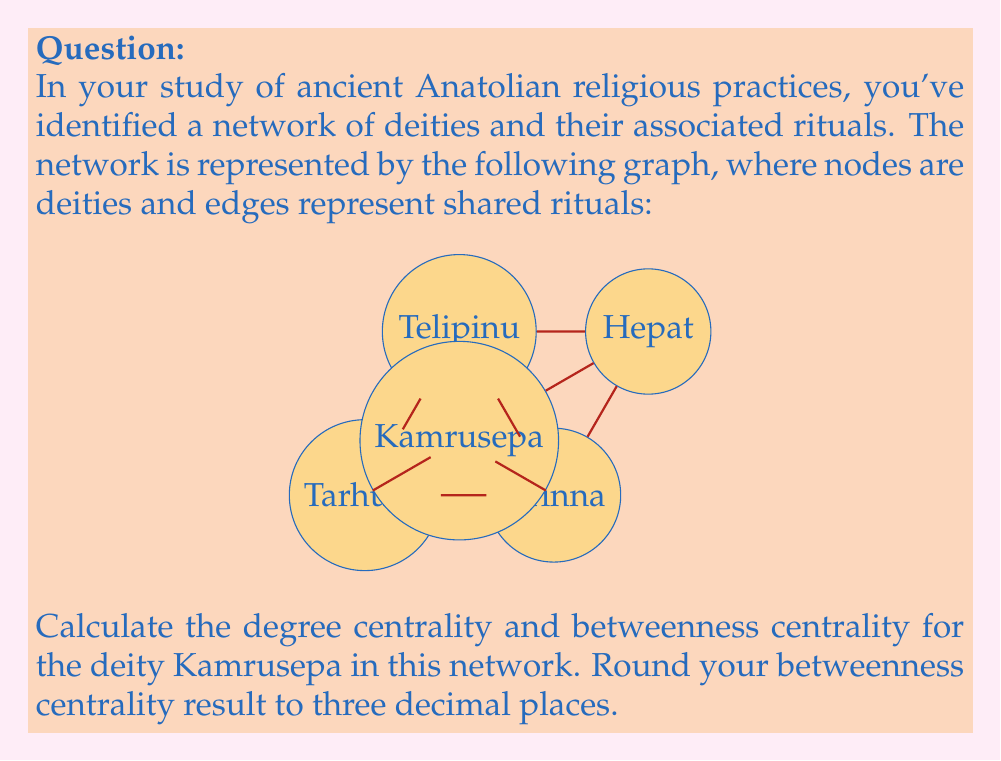Help me with this question. To solve this problem, we need to calculate two centrality measures for Kamrusepa: degree centrality and betweenness centrality.

1. Degree Centrality:
Degree centrality is the number of direct connections a node has. For Kamrusepa:
$$\text{Degree Centrality} = \text{Number of connections} = 3$$

2. Betweenness Centrality:
Betweenness centrality measures how often a node appears on the shortest paths between other nodes.

Step 1: Identify all shortest paths in the network.
Step 2: Count how many of these paths pass through Kamrusepa.
Step 3: Calculate the betweenness centrality using the formula:

$$C_B(v) = \sum_{s \neq v \neq t} \frac{\sigma_{st}(v)}{\sigma_{st}}$$

Where:
$\sigma_{st}$ is the total number of shortest paths from node $s$ to node $t$
$\sigma_{st}(v)$ is the number of those paths that pass through $v$

For Kamrusepa:
- Tarhunz to Hepat: 1 path through Kamrusepa out of 2 total
- Tarhunz to Telipinu: 0 paths through Kamrusepa out of 1 total
- Arinna to Telipinu: 0 paths through Kamrusepa out of 1 total
- Tarhunz to Arinna: 1 path through Kamrusepa out of 1 total

$$C_B(\text{Kamrusepa}) = \frac{1}{2} + 0 + 0 + 1 = 1.5$$

The normalized betweenness centrality (dividing by the maximum possible value) is:

$$C'_B(\text{Kamrusepa}) = \frac{1.5}{(N-1)(N-2)/2} = \frac{1.5}{6} = 0.25$$

Where $N$ is the number of nodes (5 in this case).

Rounding to three decimal places: 0.250
Answer: Degree centrality: 3, Betweenness centrality: 0.250 